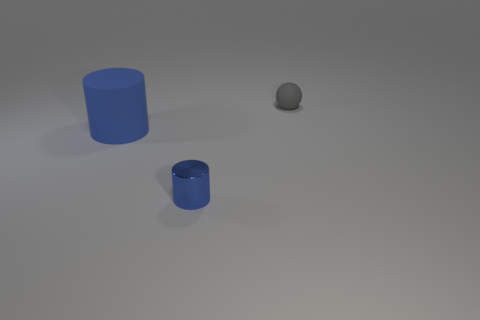What number of small cylinders are the same material as the small blue thing?
Your answer should be very brief. 0. What color is the thing that is the same material as the large blue cylinder?
Provide a short and direct response. Gray. There is a blue matte cylinder; does it have the same size as the thing that is on the right side of the tiny blue thing?
Keep it short and to the point. No. What is the material of the small thing behind the blue thing to the right of the rubber thing in front of the gray thing?
Provide a short and direct response. Rubber. What number of objects are either small red metal cylinders or large matte cylinders?
Provide a succinct answer. 1. There is a object on the left side of the tiny metal cylinder; is it the same color as the tiny thing behind the big cylinder?
Provide a succinct answer. No. What shape is the matte object that is the same size as the shiny cylinder?
Your response must be concise. Sphere. How many things are either blue cylinders that are behind the small blue shiny cylinder or objects that are on the left side of the gray thing?
Your answer should be very brief. 2. Is the number of gray things less than the number of matte objects?
Your response must be concise. Yes. There is a blue thing that is the same size as the rubber sphere; what is its material?
Offer a terse response. Metal. 